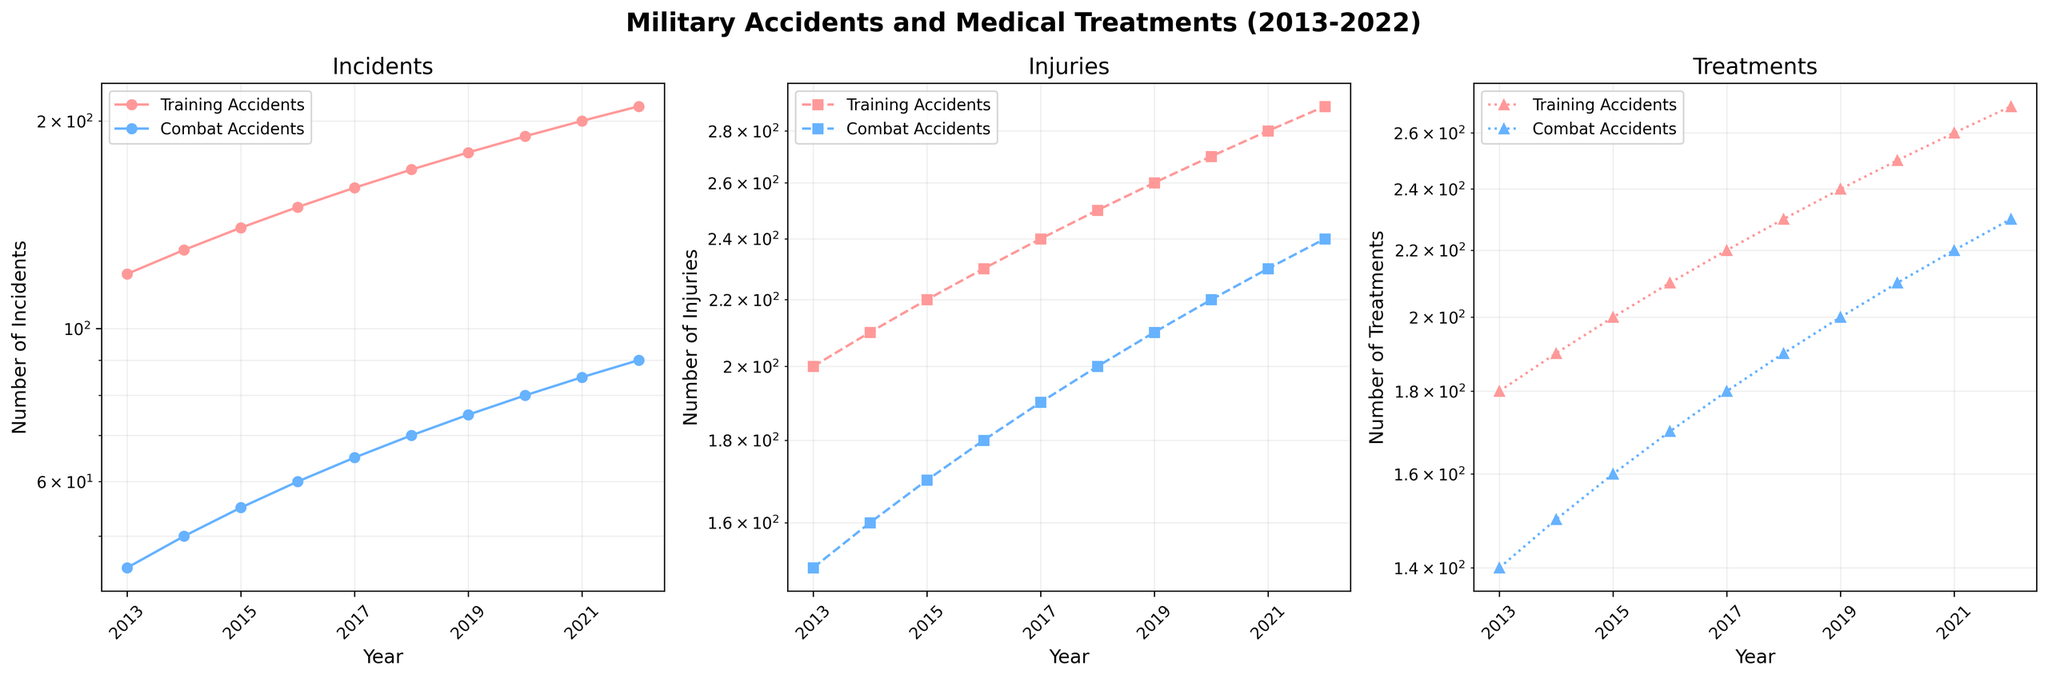What's the title of the figure? The title of the figure is displayed prominently at the top center of the plot.
Answer: "Military Accidents and Medical Treatments (2013-2022)" What are the colors used to differentiate between Training and Combat Accidents? The colors can be interpreted from the legend present on each subplot. The solid lines, dashed lines, and dotted lines each represent Training and Combat Accidents with different colors.
Answer: Red and Blue Which year had the highest number of Combat Accidents? Evaluate the "Number of Incidents" subplot and find the year with the highest marker for Combat_Accidents between 2013 and 2022.
Answer: 2022 How does the number of injuries in Training Accidents in 2020 compare to those in 2013? Locate the markers for Training Accidents on the "Injuries" subplot in 2013 and 2020. The number of injuries in 2020 appears higher.
Answer: Higher in 2020 What is the trend in the number of treatments for Training Accidents over the decade? Observe the "Number of Treatments" subplot, follow the solid line representing Training Accidents from 2013 to 2022. The line consistently rises, indicating an increasing trend.
Answer: Increasing By how much do the Training Accident incidents increase from 2013 to 2022? From the "Number of Incidents" subplot, note the number of Training Accidents in 2013 (120) and in 2022 (210). Calculate the difference.
Answer: 90 On which subplots do we see the use of a semi-logarithmic scale? Examine the axis labels and the scale used for each subplot. All three subplots use a semi-logarithmic scale on the y-axis to plot the data.
Answer: All subplots What was the overall pattern in the number of injuries from Combat Accidents from 2013 to 2022? Look at the "Injuries" subplot, following the dashed line of Combat Accidents over the years. The number increases steadily across the decade.
Answer: Increasing steadily Which type of accident consistently resulted in more treatments across all years? Compare the markers corresponding to Training and Combat Accidents in the "Treatments" subplot each year. Training Accidents consistently show higher values.
Answer: Training Accidents 